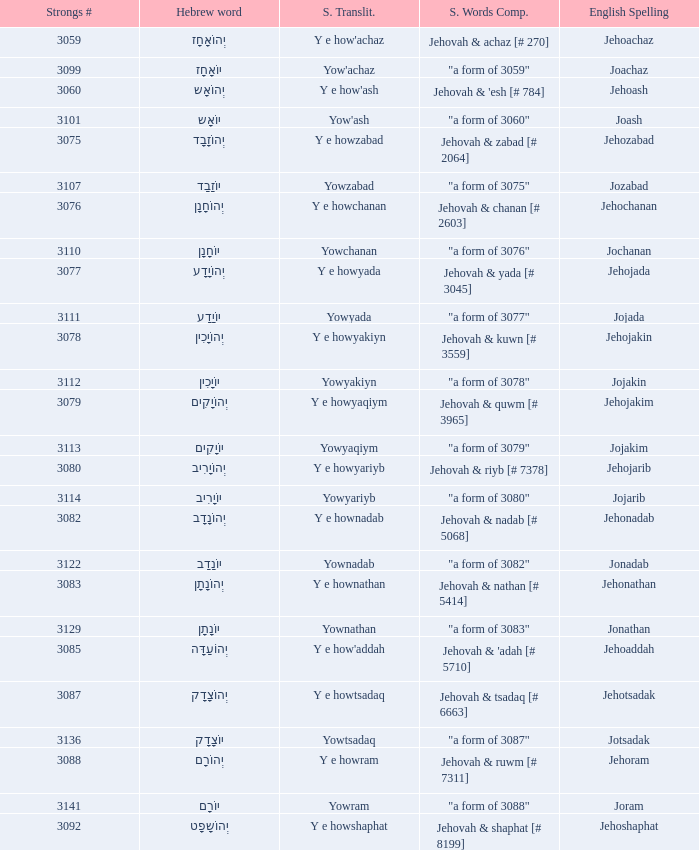What is the strongs # of the english spelling word jehojakin? 3078.0. 